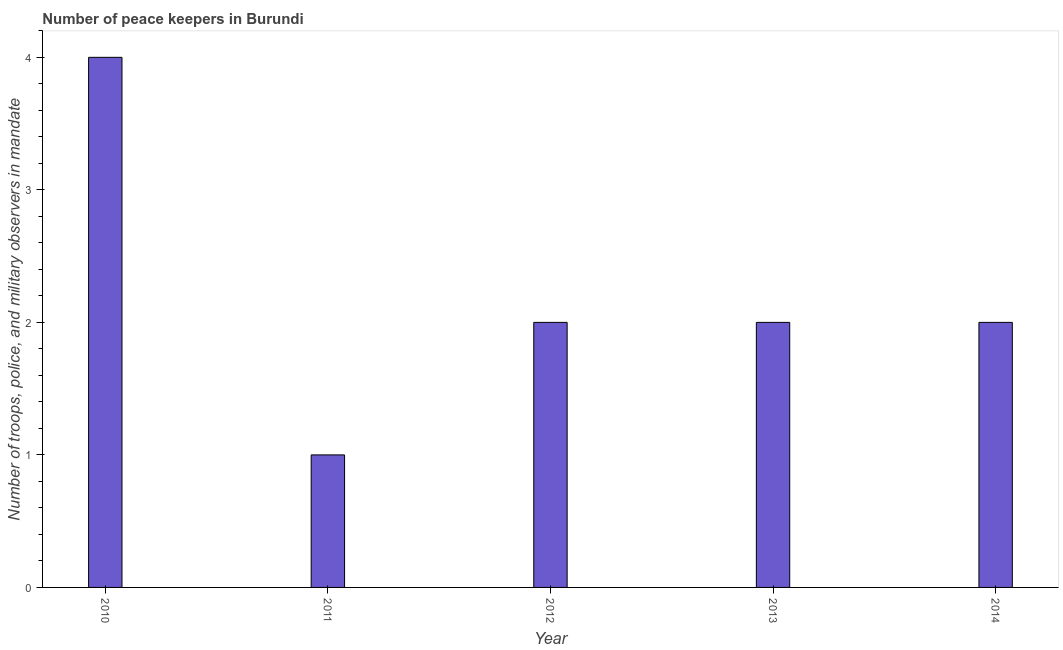What is the title of the graph?
Offer a very short reply. Number of peace keepers in Burundi. What is the label or title of the X-axis?
Ensure brevity in your answer.  Year. What is the label or title of the Y-axis?
Ensure brevity in your answer.  Number of troops, police, and military observers in mandate. What is the number of peace keepers in 2012?
Make the answer very short. 2. In which year was the number of peace keepers maximum?
Provide a short and direct response. 2010. In which year was the number of peace keepers minimum?
Provide a short and direct response. 2011. What is the median number of peace keepers?
Keep it short and to the point. 2. In how many years, is the number of peace keepers greater than 0.6 ?
Your response must be concise. 5. Do a majority of the years between 2011 and 2013 (inclusive) have number of peace keepers greater than 0.2 ?
Give a very brief answer. Yes. What is the ratio of the number of peace keepers in 2012 to that in 2014?
Your response must be concise. 1. Is the sum of the number of peace keepers in 2010 and 2014 greater than the maximum number of peace keepers across all years?
Make the answer very short. Yes. In how many years, is the number of peace keepers greater than the average number of peace keepers taken over all years?
Provide a succinct answer. 1. How many bars are there?
Provide a short and direct response. 5. Are the values on the major ticks of Y-axis written in scientific E-notation?
Provide a succinct answer. No. What is the Number of troops, police, and military observers in mandate in 2013?
Give a very brief answer. 2. What is the difference between the Number of troops, police, and military observers in mandate in 2010 and 2012?
Your response must be concise. 2. What is the difference between the Number of troops, police, and military observers in mandate in 2010 and 2014?
Provide a succinct answer. 2. What is the difference between the Number of troops, police, and military observers in mandate in 2011 and 2013?
Your answer should be compact. -1. What is the difference between the Number of troops, police, and military observers in mandate in 2011 and 2014?
Offer a terse response. -1. What is the difference between the Number of troops, police, and military observers in mandate in 2012 and 2014?
Give a very brief answer. 0. What is the ratio of the Number of troops, police, and military observers in mandate in 2010 to that in 2013?
Offer a terse response. 2. What is the ratio of the Number of troops, police, and military observers in mandate in 2011 to that in 2014?
Your answer should be compact. 0.5. What is the ratio of the Number of troops, police, and military observers in mandate in 2012 to that in 2013?
Provide a succinct answer. 1. What is the ratio of the Number of troops, police, and military observers in mandate in 2012 to that in 2014?
Your response must be concise. 1. What is the ratio of the Number of troops, police, and military observers in mandate in 2013 to that in 2014?
Give a very brief answer. 1. 